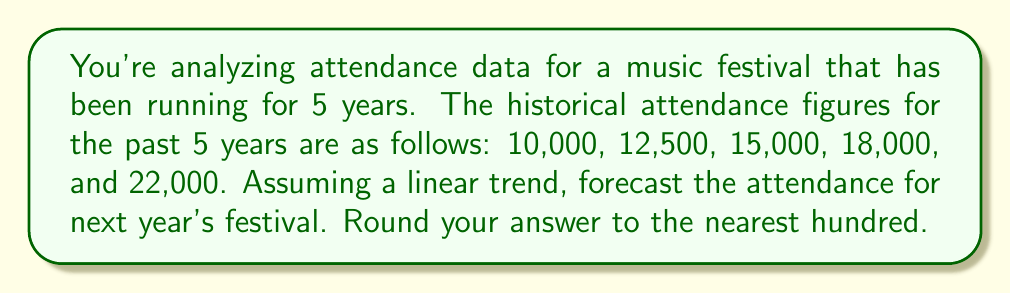Teach me how to tackle this problem. To forecast the attendance for next year's festival assuming a linear trend, we'll use the linear regression method.

1) First, let's set up our data:
   Year (x): 1, 2, 3, 4, 5
   Attendance (y): 10000, 12500, 15000, 18000, 22000

2) We need to calculate the following:
   $\bar{x} = \frac{1+2+3+4+5}{5} = 3$
   $\bar{y} = \frac{10000+12500+15000+18000+22000}{5} = 15500$

3) Now, we calculate the slope (b) using the formula:
   $$b = \frac{\sum(x-\bar{x})(y-\bar{y})}{\sum(x-\bar{x})^2}$$

4) Let's calculate the numerator and denominator:
   $\sum(x-\bar{x})(y-\bar{y}) = (-2)(-5500) + (-1)(-3000) + (0)(-500) + (1)(2500) + (2)(6500) = 25000$
   $\sum(x-\bar{x})^2 = (-2)^2 + (-1)^2 + (0)^2 + (1)^2 + (2)^2 = 10$

5) Now we can calculate b:
   $$b = \frac{25000}{10} = 2500$$

6) We can find the y-intercept (a) using:
   $$a = \bar{y} - b\bar{x} = 15500 - 2500(3) = 8000$$

7) Our linear equation is:
   $$y = 8000 + 2500x$$

8) To forecast for next year (year 6), we plug in x = 6:
   $$y = 8000 + 2500(6) = 23000$$

Therefore, the forecasted attendance for next year's festival is 23,000.
Answer: 23,000 